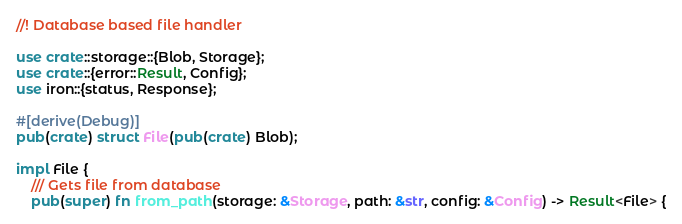<code> <loc_0><loc_0><loc_500><loc_500><_Rust_>//! Database based file handler

use crate::storage::{Blob, Storage};
use crate::{error::Result, Config};
use iron::{status, Response};

#[derive(Debug)]
pub(crate) struct File(pub(crate) Blob);

impl File {
    /// Gets file from database
    pub(super) fn from_path(storage: &Storage, path: &str, config: &Config) -> Result<File> {</code> 